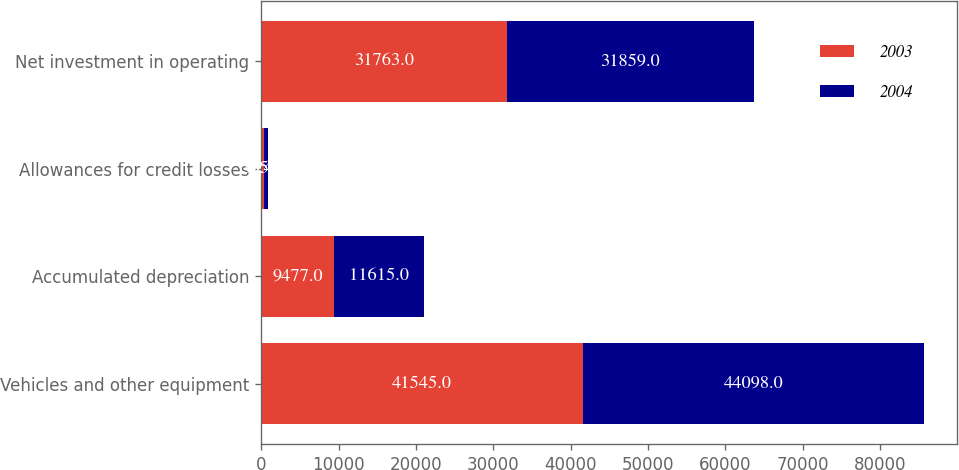Convert chart. <chart><loc_0><loc_0><loc_500><loc_500><stacked_bar_chart><ecel><fcel>Vehicles and other equipment<fcel>Accumulated depreciation<fcel>Allowances for credit losses<fcel>Net investment in operating<nl><fcel>2003<fcel>41545<fcel>9477<fcel>305<fcel>31763<nl><fcel>2004<fcel>44098<fcel>11615<fcel>624<fcel>31859<nl></chart> 